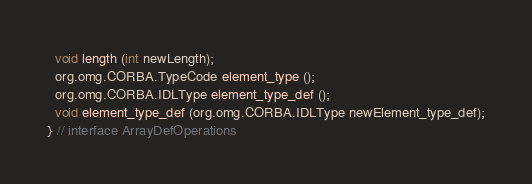<code> <loc_0><loc_0><loc_500><loc_500><_Java_>  void length (int newLength);
  org.omg.CORBA.TypeCode element_type ();
  org.omg.CORBA.IDLType element_type_def ();
  void element_type_def (org.omg.CORBA.IDLType newElement_type_def);
} // interface ArrayDefOperations
</code> 